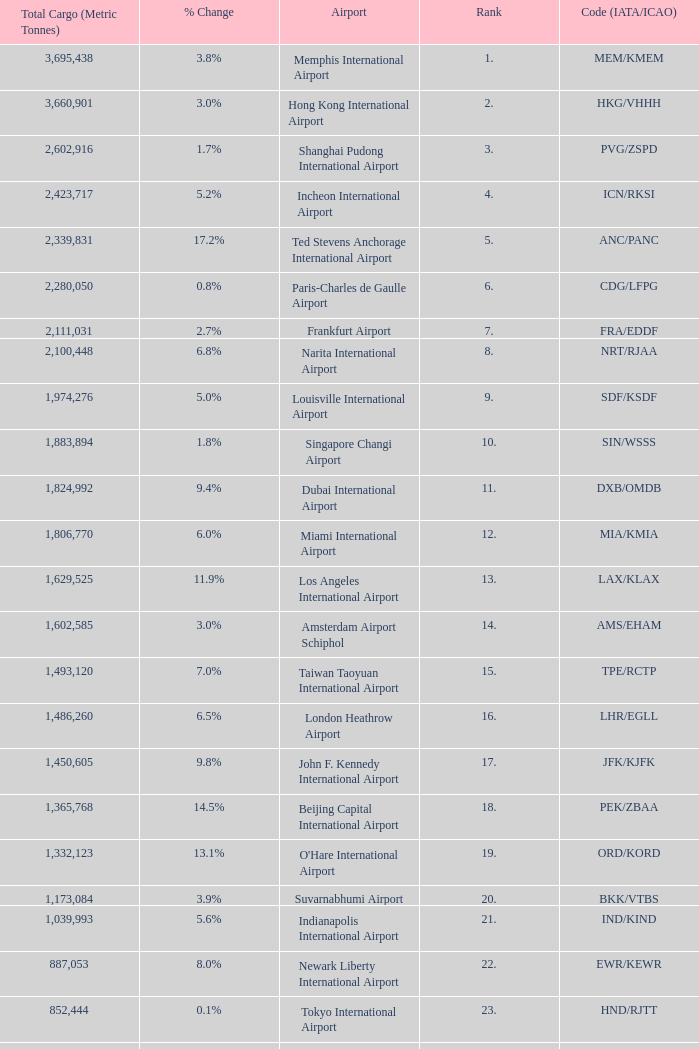What is the code for rank 10? SIN/WSSS. 